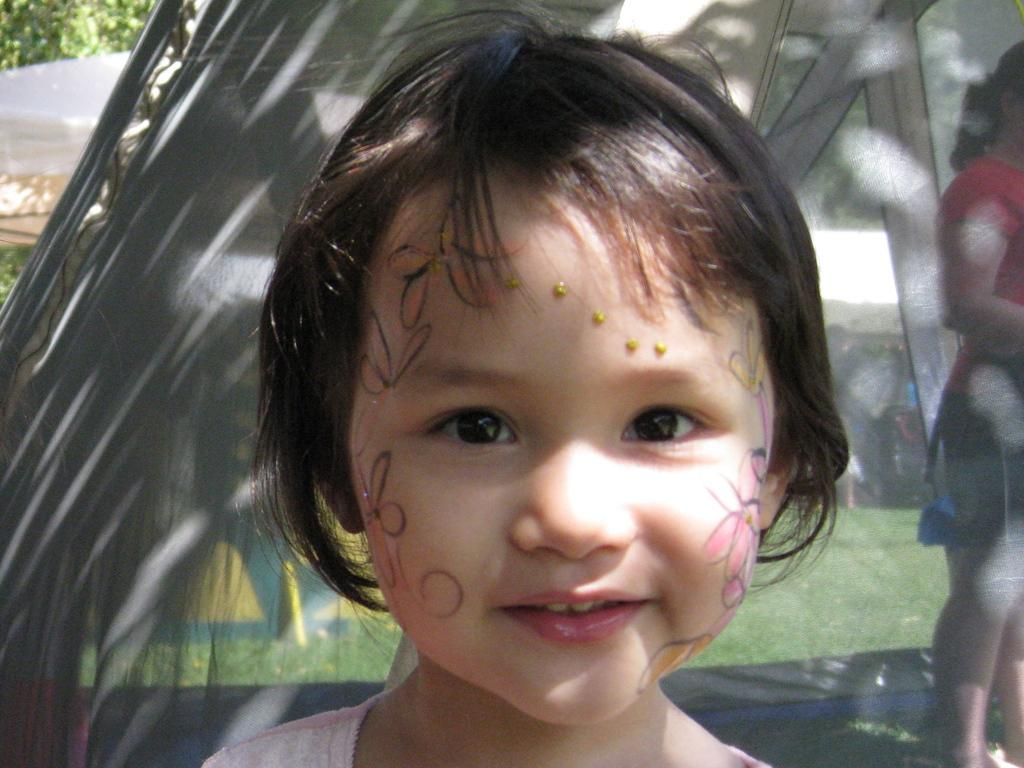Who is present in the image? There is a child in the image. What is the child doing in the image? There is a girl standing inside a tent in the image. What type of terrain is visible in the image? There is grass visible in the image. What can be seen in the background of the image? There are trees in the image. What type of chain is being used for the activity in the image? There is no chain present in the image, and no activity involving a chain is depicted. 